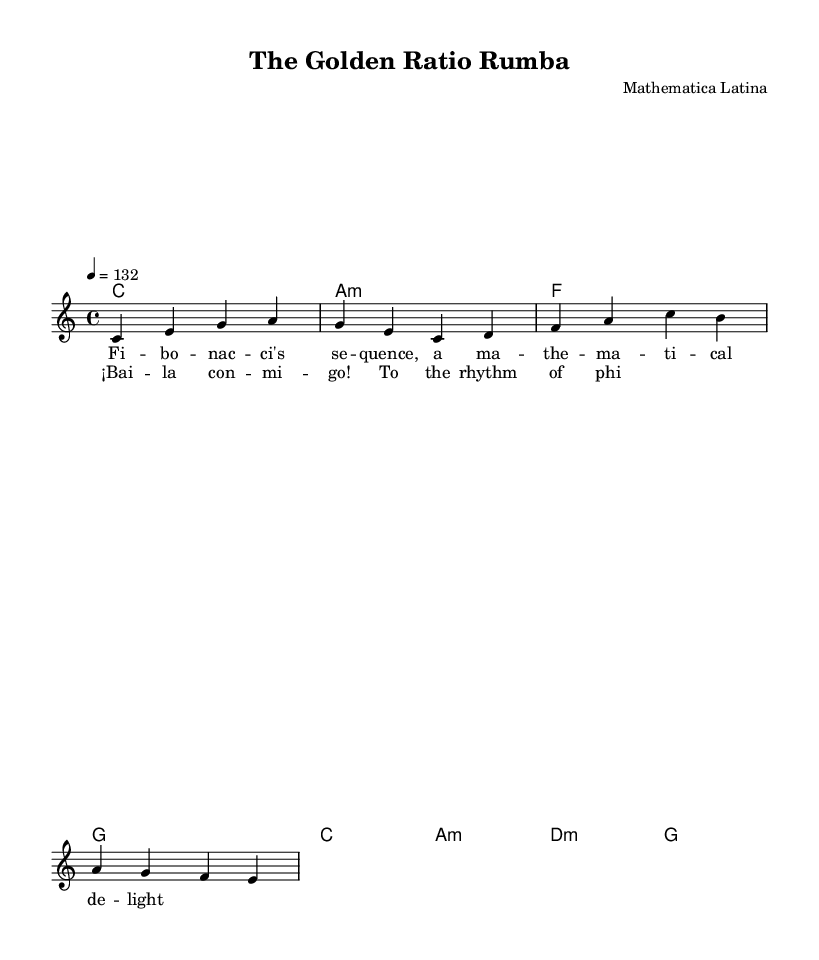What is the key signature of this music? The key signature is C major, which has no sharps or flats.
Answer: C major What is the time signature of this music? The time signature is indicated at the beginning of the piece as 4/4, which means there are four beats in a measure and a quarter note gets one beat.
Answer: 4/4 What is the tempo marking of this piece? The tempo marking indicates a tempo of 132 beats per minute, denoted by the text "4 = 132," meaning there are 132 quarter-note beats in one minute.
Answer: 132 How many measures are in the melody? By counting the sequences of bars in the melody section, there are a total of four measures visible, with each separated by a vertical line.
Answer: 4 What is the first note of the melody? The first note of the melody is C, as it appears at the very beginning of the melody staff.
Answer: C What kind of musical style does this piece represent? Given the title "The Golden Ratio Rumba" and the lively tempo, it reflects a typical Latin pop style, particularly a type of rumba known for its upbeat and danceable rhythms.
Answer: Latin pop Which mathematician's concept is referenced in the chorus? The chorus has a reference to “phi,” which is commonly associated with the golden ratio, a notable mathematical concept connected to beauty and aesthetics.
Answer: phi 